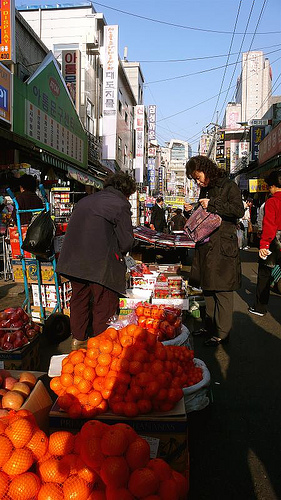Please provide a short description for this region: [0.32, 0.34, 0.71, 0.59]. Both women in this area are wearing coats, suggesting a cooler weather or seasonal setting, which adds to the understanding of the market scene. 